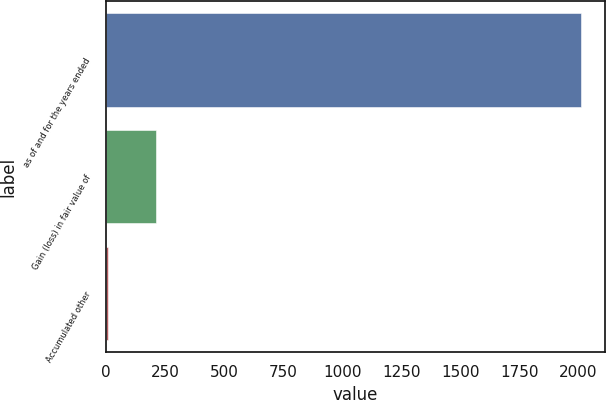Convert chart to OTSL. <chart><loc_0><loc_0><loc_500><loc_500><bar_chart><fcel>as of and for the years ended<fcel>Gain (loss) in fair value of<fcel>Accumulated other<nl><fcel>2013<fcel>210.3<fcel>10<nl></chart> 